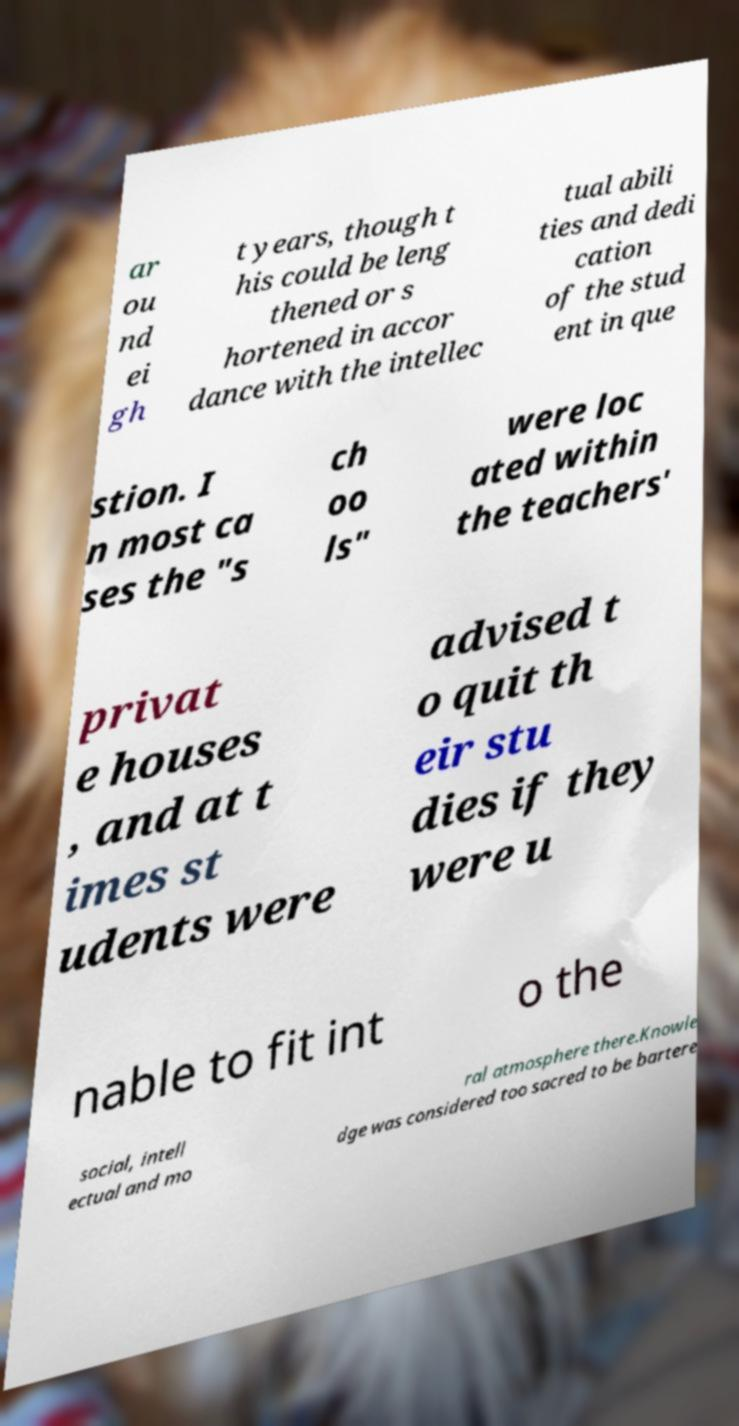Could you assist in decoding the text presented in this image and type it out clearly? ar ou nd ei gh t years, though t his could be leng thened or s hortened in accor dance with the intellec tual abili ties and dedi cation of the stud ent in que stion. I n most ca ses the "s ch oo ls" were loc ated within the teachers' privat e houses , and at t imes st udents were advised t o quit th eir stu dies if they were u nable to fit int o the social, intell ectual and mo ral atmosphere there.Knowle dge was considered too sacred to be bartere 